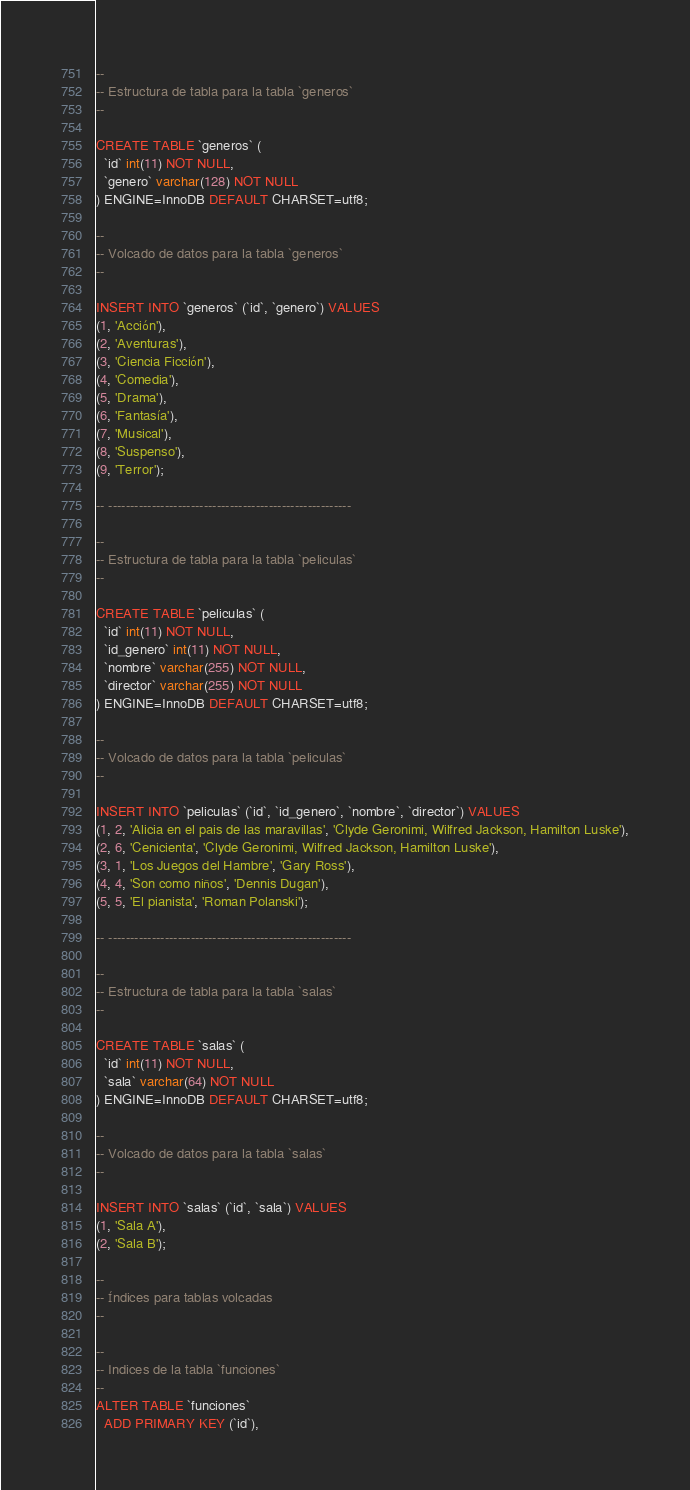Convert code to text. <code><loc_0><loc_0><loc_500><loc_500><_SQL_>--
-- Estructura de tabla para la tabla `generos`
--

CREATE TABLE `generos` (
  `id` int(11) NOT NULL,
  `genero` varchar(128) NOT NULL
) ENGINE=InnoDB DEFAULT CHARSET=utf8;

--
-- Volcado de datos para la tabla `generos`
--

INSERT INTO `generos` (`id`, `genero`) VALUES
(1, 'Acción'),
(2, 'Aventuras'),
(3, 'Ciencia Ficción'),
(4, 'Comedia'),
(5, 'Drama'),
(6, 'Fantasía'),
(7, 'Musical'),
(8, 'Suspenso'),
(9, 'Terror');

-- --------------------------------------------------------

--
-- Estructura de tabla para la tabla `peliculas`
--

CREATE TABLE `peliculas` (
  `id` int(11) NOT NULL,
  `id_genero` int(11) NOT NULL,
  `nombre` varchar(255) NOT NULL,
  `director` varchar(255) NOT NULL
) ENGINE=InnoDB DEFAULT CHARSET=utf8;

--
-- Volcado de datos para la tabla `peliculas`
--

INSERT INTO `peliculas` (`id`, `id_genero`, `nombre`, `director`) VALUES
(1, 2, 'Alicia en el pais de las maravillas', 'Clyde Geronimi, Wilfred Jackson, Hamilton Luske'),
(2, 6, 'Cenicienta', 'Clyde Geronimi, Wilfred Jackson, Hamilton Luske'),
(3, 1, 'Los Juegos del Hambre', 'Gary Ross'),
(4, 4, 'Son como niños', 'Dennis Dugan'),
(5, 5, 'El pianista', 'Roman Polanski');

-- --------------------------------------------------------

--
-- Estructura de tabla para la tabla `salas`
--

CREATE TABLE `salas` (
  `id` int(11) NOT NULL,
  `sala` varchar(64) NOT NULL
) ENGINE=InnoDB DEFAULT CHARSET=utf8;

--
-- Volcado de datos para la tabla `salas`
--

INSERT INTO `salas` (`id`, `sala`) VALUES
(1, 'Sala A'),
(2, 'Sala B');

--
-- Índices para tablas volcadas
--

--
-- Indices de la tabla `funciones`
--
ALTER TABLE `funciones`
  ADD PRIMARY KEY (`id`),</code> 